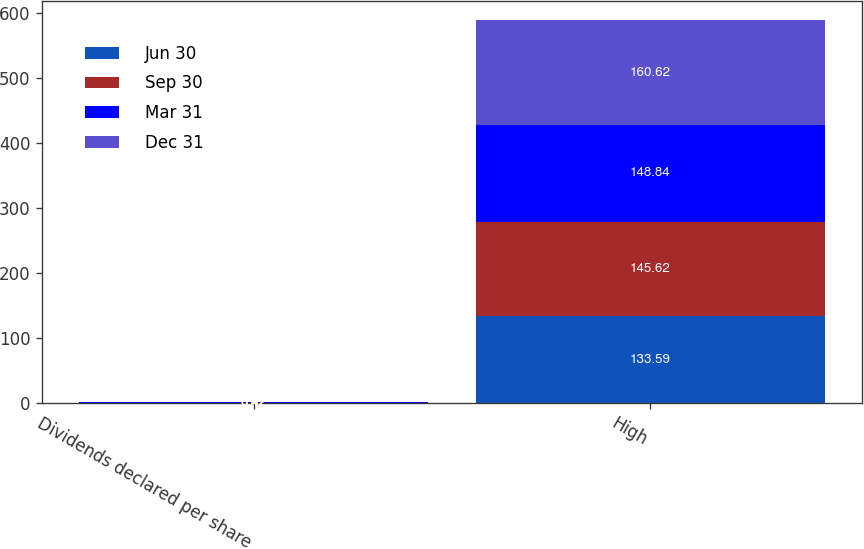<chart> <loc_0><loc_0><loc_500><loc_500><stacked_bar_chart><ecel><fcel>Dividends declared per share<fcel>High<nl><fcel>Jun 30<fcel>0.42<fcel>133.59<nl><fcel>Sep 30<fcel>0.42<fcel>145.62<nl><fcel>Mar 31<fcel>0.42<fcel>148.84<nl><fcel>Dec 31<fcel>0.47<fcel>160.62<nl></chart> 